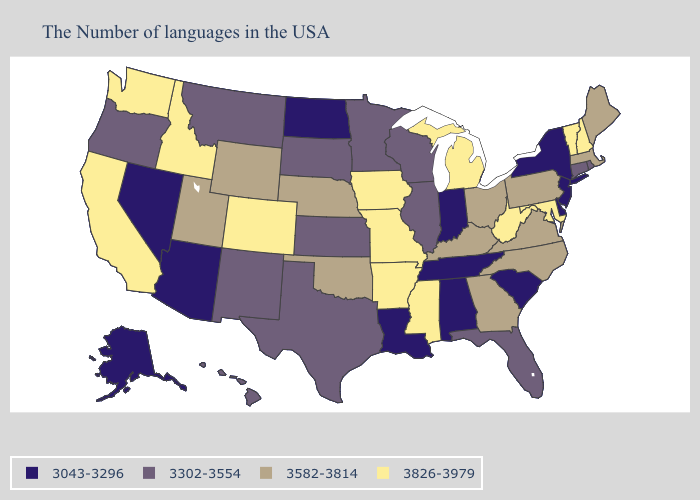Name the states that have a value in the range 3582-3814?
Give a very brief answer. Maine, Massachusetts, Pennsylvania, Virginia, North Carolina, Ohio, Georgia, Kentucky, Nebraska, Oklahoma, Wyoming, Utah. What is the highest value in states that border Nebraska?
Quick response, please. 3826-3979. Which states have the highest value in the USA?
Give a very brief answer. New Hampshire, Vermont, Maryland, West Virginia, Michigan, Mississippi, Missouri, Arkansas, Iowa, Colorado, Idaho, California, Washington. What is the value of Idaho?
Give a very brief answer. 3826-3979. Name the states that have a value in the range 3043-3296?
Give a very brief answer. New York, New Jersey, Delaware, South Carolina, Indiana, Alabama, Tennessee, Louisiana, North Dakota, Arizona, Nevada, Alaska. What is the value of Pennsylvania?
Keep it brief. 3582-3814. Among the states that border West Virginia , which have the lowest value?
Concise answer only. Pennsylvania, Virginia, Ohio, Kentucky. What is the value of Nevada?
Concise answer only. 3043-3296. Does Vermont have a higher value than Minnesota?
Concise answer only. Yes. Name the states that have a value in the range 3043-3296?
Concise answer only. New York, New Jersey, Delaware, South Carolina, Indiana, Alabama, Tennessee, Louisiana, North Dakota, Arizona, Nevada, Alaska. Does Minnesota have the highest value in the MidWest?
Answer briefly. No. Which states have the lowest value in the USA?
Concise answer only. New York, New Jersey, Delaware, South Carolina, Indiana, Alabama, Tennessee, Louisiana, North Dakota, Arizona, Nevada, Alaska. Which states have the lowest value in the USA?
Concise answer only. New York, New Jersey, Delaware, South Carolina, Indiana, Alabama, Tennessee, Louisiana, North Dakota, Arizona, Nevada, Alaska. Does North Dakota have a higher value than Delaware?
Be succinct. No. 